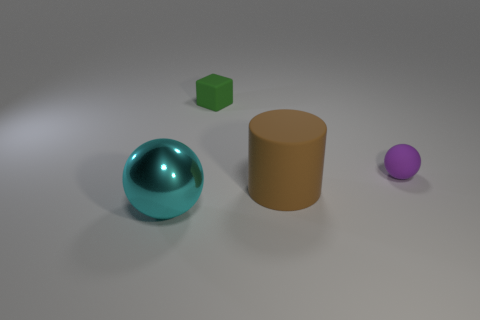The object behind the tiny matte object that is in front of the matte thing that is behind the tiny purple matte object is made of what material?
Make the answer very short. Rubber. How many tiny balls are the same material as the brown cylinder?
Ensure brevity in your answer.  1. There is a purple rubber thing that is in front of the cube; is its size the same as the big brown matte thing?
Make the answer very short. No. There is a block that is the same material as the small purple sphere; what is its color?
Make the answer very short. Green. Is there anything else that is the same size as the cylinder?
Your answer should be compact. Yes. How many matte cylinders are to the right of the small ball?
Offer a very short reply. 0. Is the color of the rubber object right of the large brown rubber cylinder the same as the object that is behind the purple matte ball?
Provide a short and direct response. No. There is another object that is the same shape as the metal thing; what color is it?
Make the answer very short. Purple. Is there anything else that is the same shape as the small green rubber object?
Give a very brief answer. No. There is a matte thing in front of the small purple thing; does it have the same shape as the tiny thing that is in front of the small cube?
Your answer should be compact. No. 